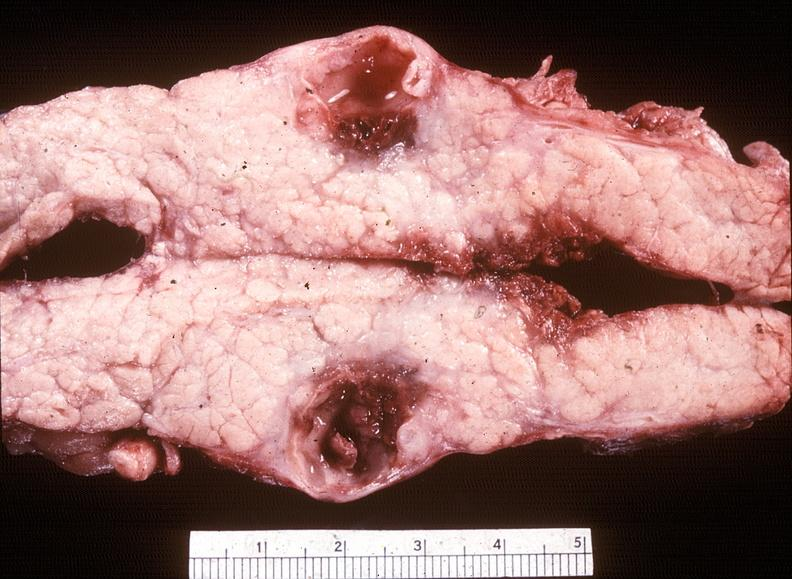how does this image show chronic pancreatitis?
Answer the question using a single word or phrase. With cyst formation 